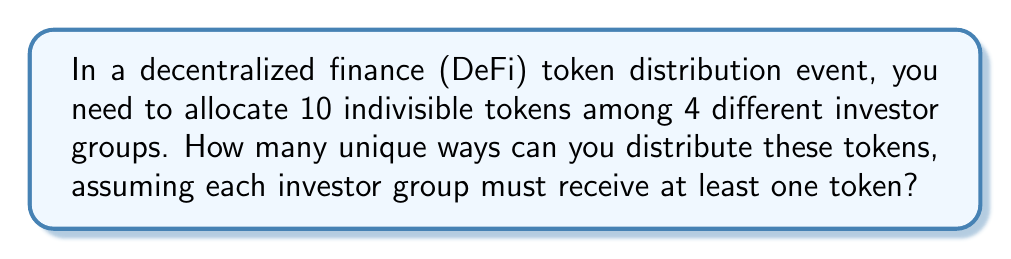Can you answer this question? Let's approach this step-by-step using the concept of stars and bars from combinatorics:

1) This problem can be modeled as distributing 10 indivisible objects (tokens) into 4 distinct containers (investor groups), with the constraint that each container must have at least one object.

2) To ensure each investor group gets at least one token, we can first allocate one token to each group. This leaves us with 6 tokens to distribute freely.

3) Now, we need to find the number of ways to distribute 6 identical objects into 4 distinct containers, with no restrictions on the number of objects in each container.

4) This scenario is a classic application of the stars and bars theorem. The formula for this is:

   $$\binom{n+k-1}{k-1}$$

   Where $n$ is the number of identical objects and $k$ is the number of distinct containers.

5) In our case, $n = 6$ (remaining tokens) and $k = 4$ (investor groups).

6) Plugging these values into the formula:

   $$\binom{6+4-1}{4-1} = \binom{9}{3}$$

7) We can calculate this as:

   $$\binom{9}{3} = \frac{9!}{3!(9-3)!} = \frac{9!}{3!6!} = \frac{9 \cdot 8 \cdot 7}{3 \cdot 2 \cdot 1} = 84$$

Therefore, there are 84 unique ways to distribute the tokens among the 4 investor groups.
Answer: 84 